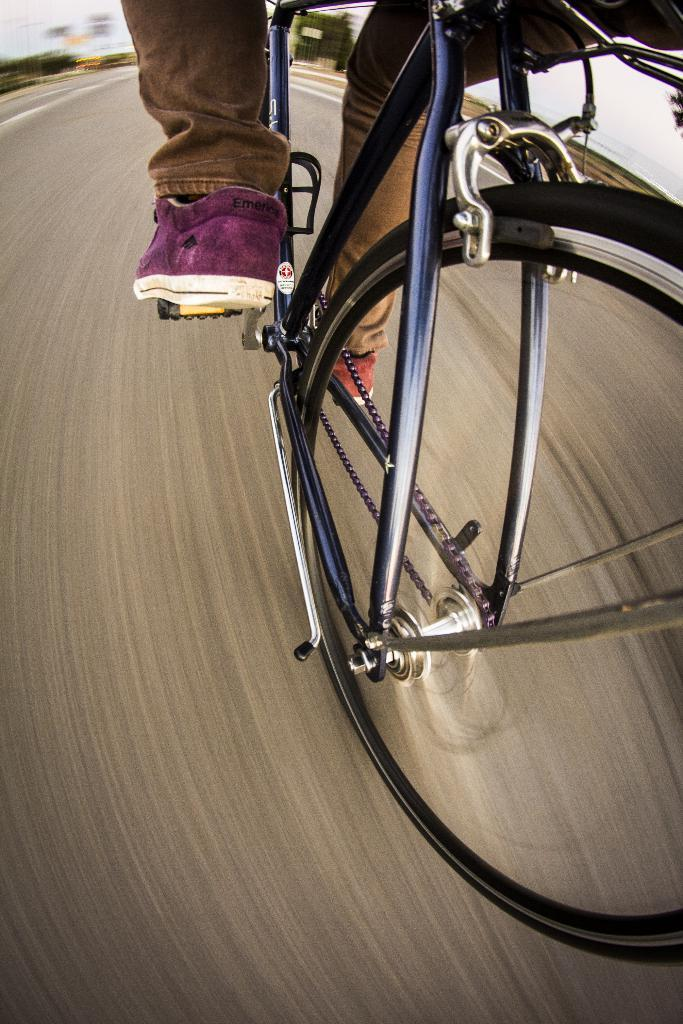What is the main subject of the image? There is a person cycling in the image. Can you describe the background of the image? The background of the image is blurred. What is visible in the foreground of the image? The foreground of the image consists of a road. What type of cloth is being used to cover the argument in the image? There is no argument or cloth present in the image; it features a person cycling on a road with a blurred background. 